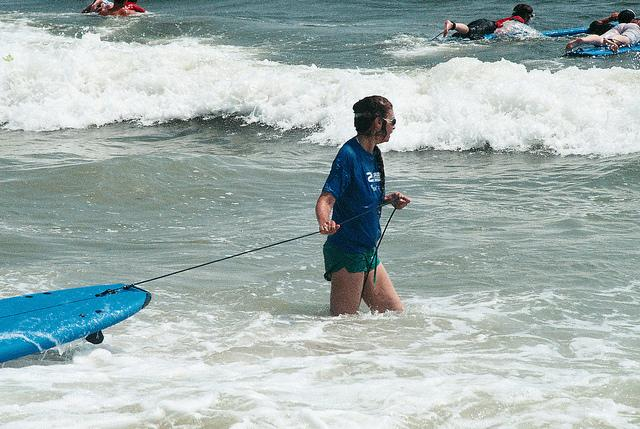What are surfboards made out of?

Choices:
A) foam
B) rubber
C) cloth
D) wood rubber 